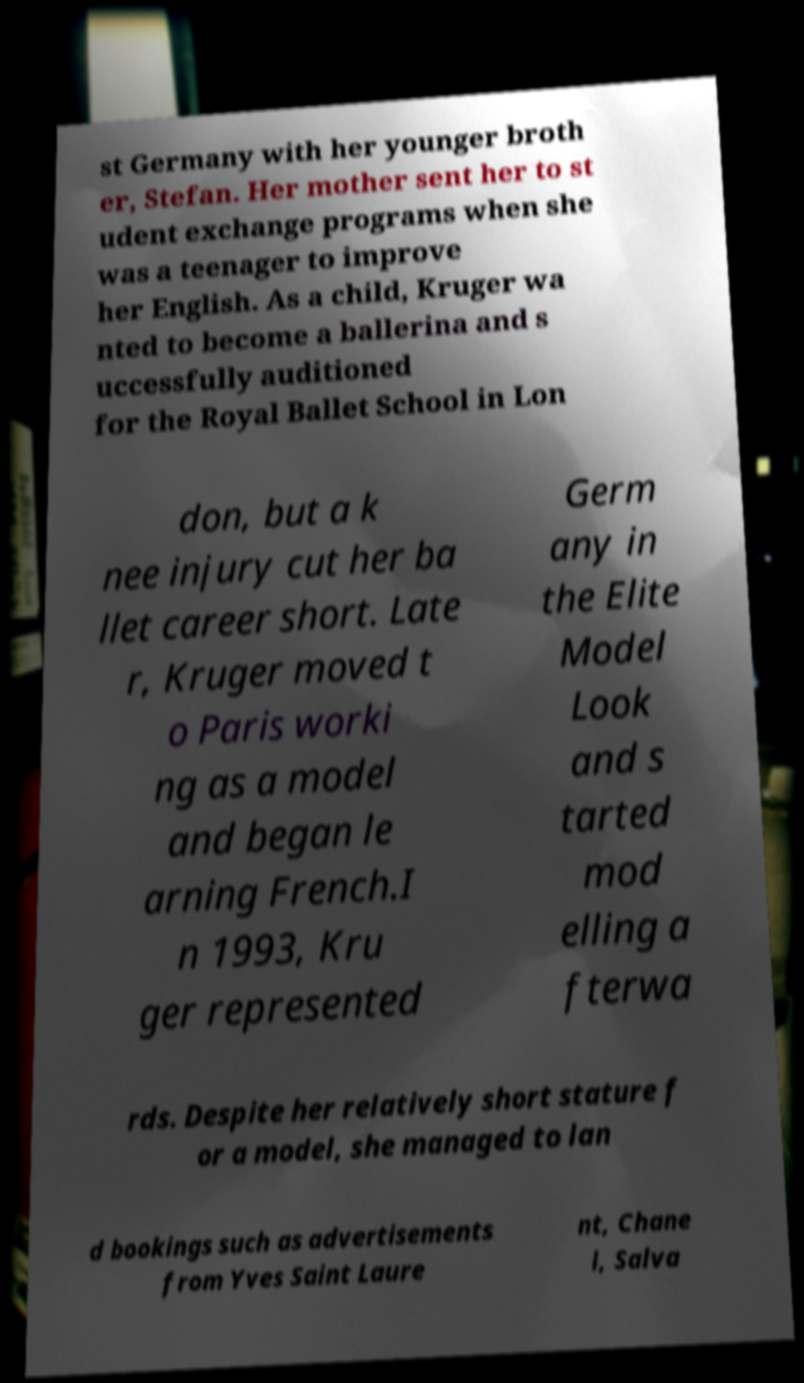There's text embedded in this image that I need extracted. Can you transcribe it verbatim? st Germany with her younger broth er, Stefan. Her mother sent her to st udent exchange programs when she was a teenager to improve her English. As a child, Kruger wa nted to become a ballerina and s uccessfully auditioned for the Royal Ballet School in Lon don, but a k nee injury cut her ba llet career short. Late r, Kruger moved t o Paris worki ng as a model and began le arning French.I n 1993, Kru ger represented Germ any in the Elite Model Look and s tarted mod elling a fterwa rds. Despite her relatively short stature f or a model, she managed to lan d bookings such as advertisements from Yves Saint Laure nt, Chane l, Salva 